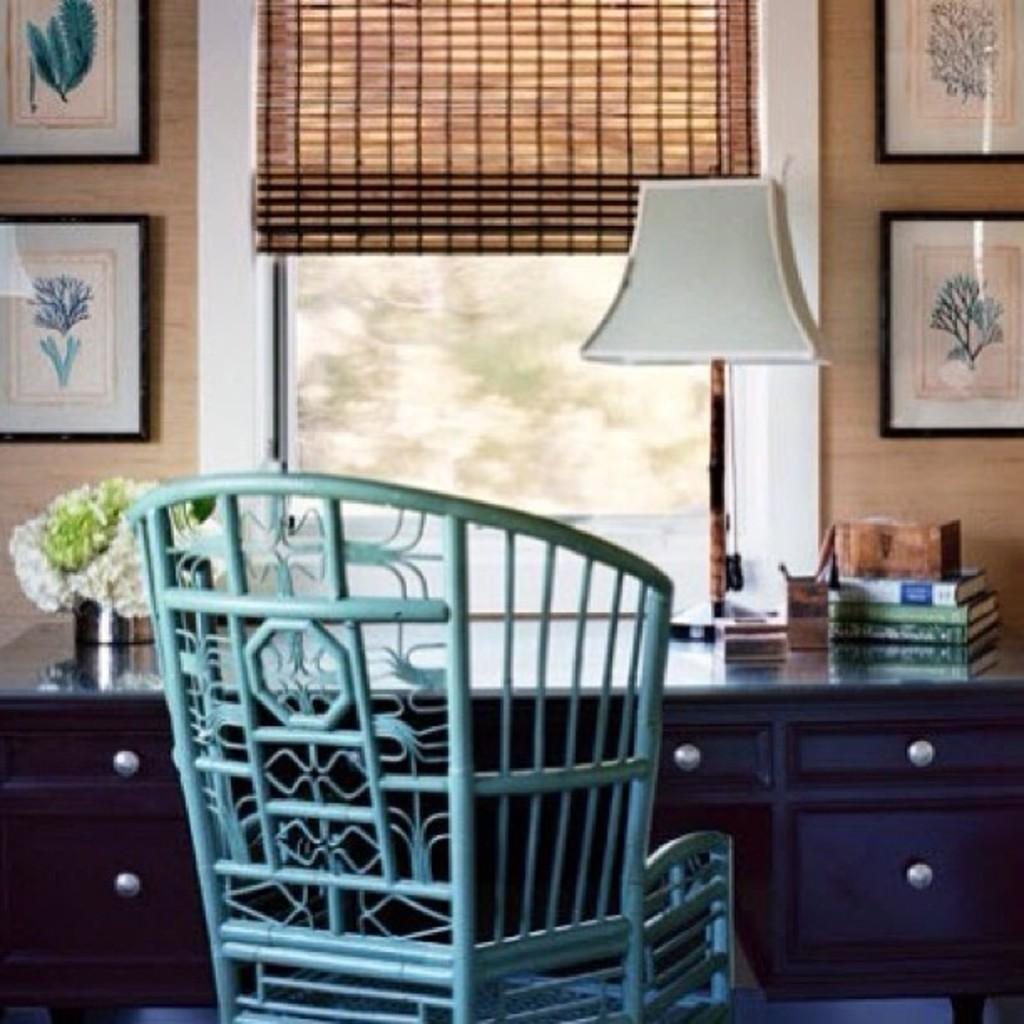What type of furniture is present in the image? There is a chair and a table in the image. What items can be seen on the table? There are books and a pen stand on the table. What additional object is present in the image? There is a lamp in the image. What can be seen on the wall in the image? There are photo frames on the wall. Is there a woman holding a parcel in the image? There is no woman or parcel present in the image. What part of the brain can be seen in the image? There is no brain visible in the image; it features a chair, table, books, pen stand, lamp, and photo frames. 